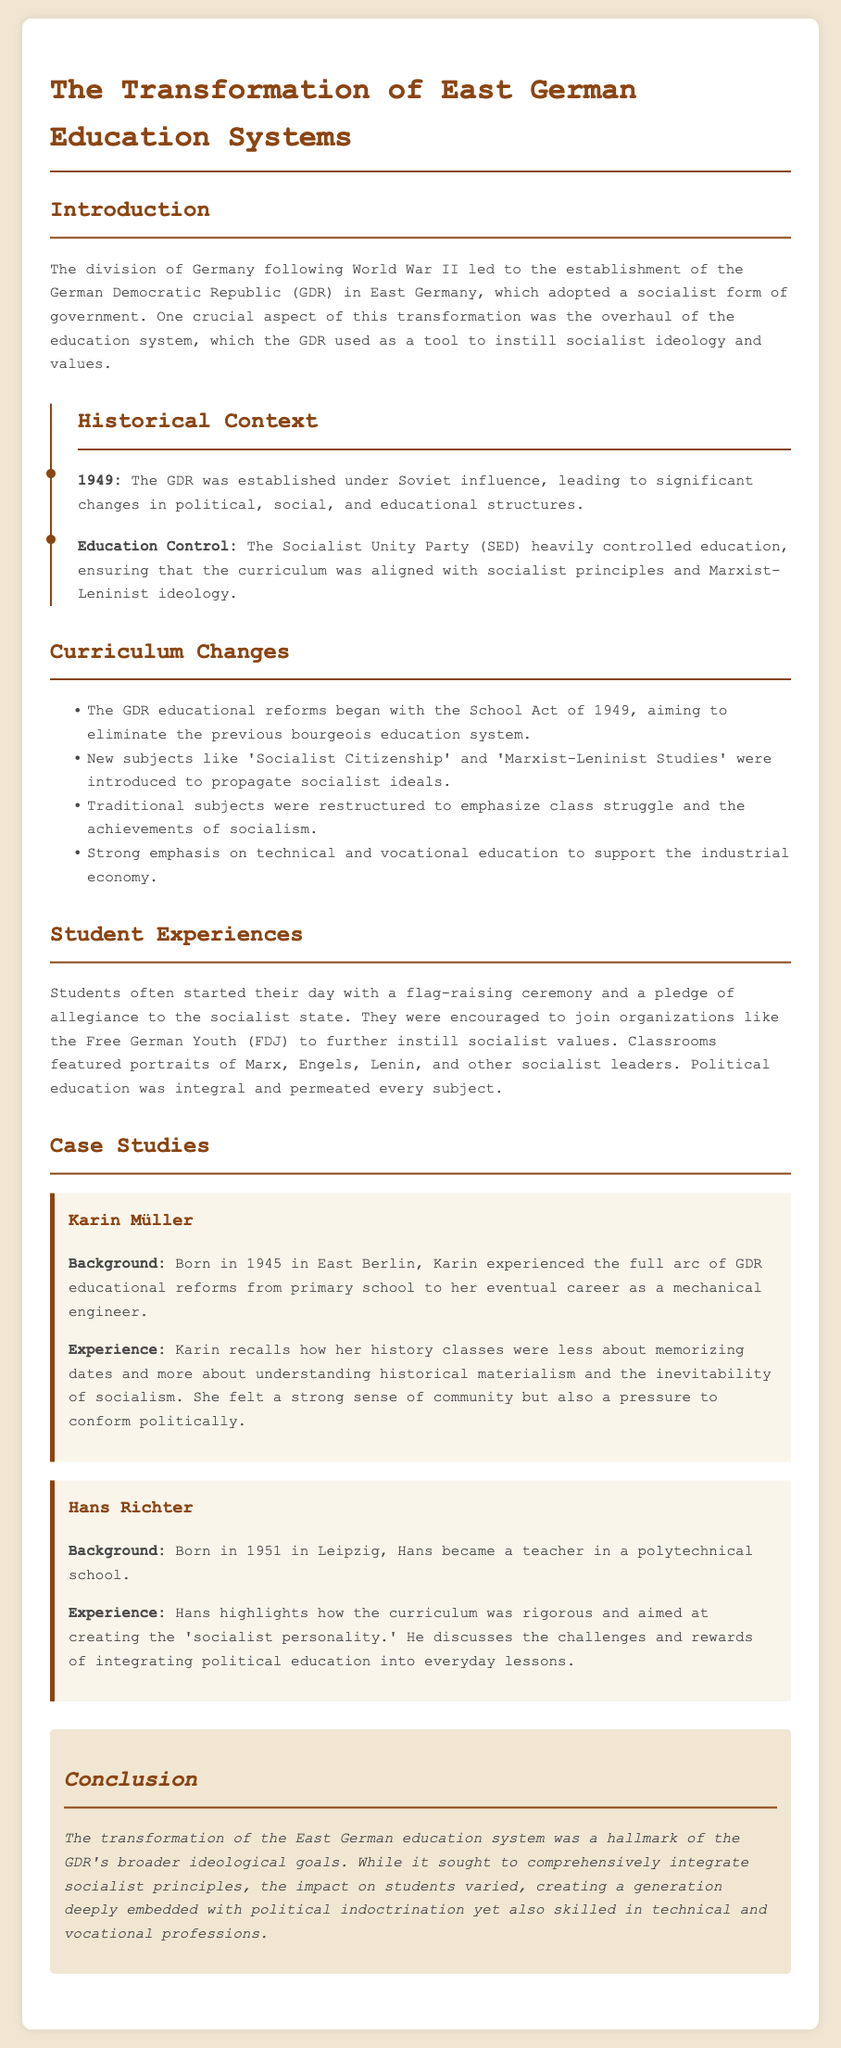what year was the GDR established? The document states that the GDR was established in 1949.
Answer: 1949 what new subject was introduced to propagate socialist ideals? The document mentions that 'Socialist Citizenship' was introduced.
Answer: Socialist Citizenship who did Karin Müller recall as a focus in her history classes? Karin remembers understanding historical materialism and the inevitability of socialism.
Answer: historical materialism what was the main goal of the education reforms initiated by the School Act of 1949? The reforms aimed to eliminate the previous bourgeois education system.
Answer: eliminate the previous bourgeois education system who highlighted the rigorous curriculum aimed at creating the 'socialist personality'? The document indicates that Hans Richter highlighted this.
Answer: Hans Richter which organization were students encouraged to join? Students were encouraged to join the Free German Youth (FDJ).
Answer: Free German Youth (FDJ) what is the overall impact on students mentioned in the conclusion? The conclusion notes that students were deeply embedded with political indoctrination.
Answer: deeply embedded with political indoctrination what profession did Karin Müller pursue after her education? The case study mentions that Karin became a mechanical engineer.
Answer: mechanical engineer what year was Hans Richter born? The document states that Hans was born in 1951.
Answer: 1951 